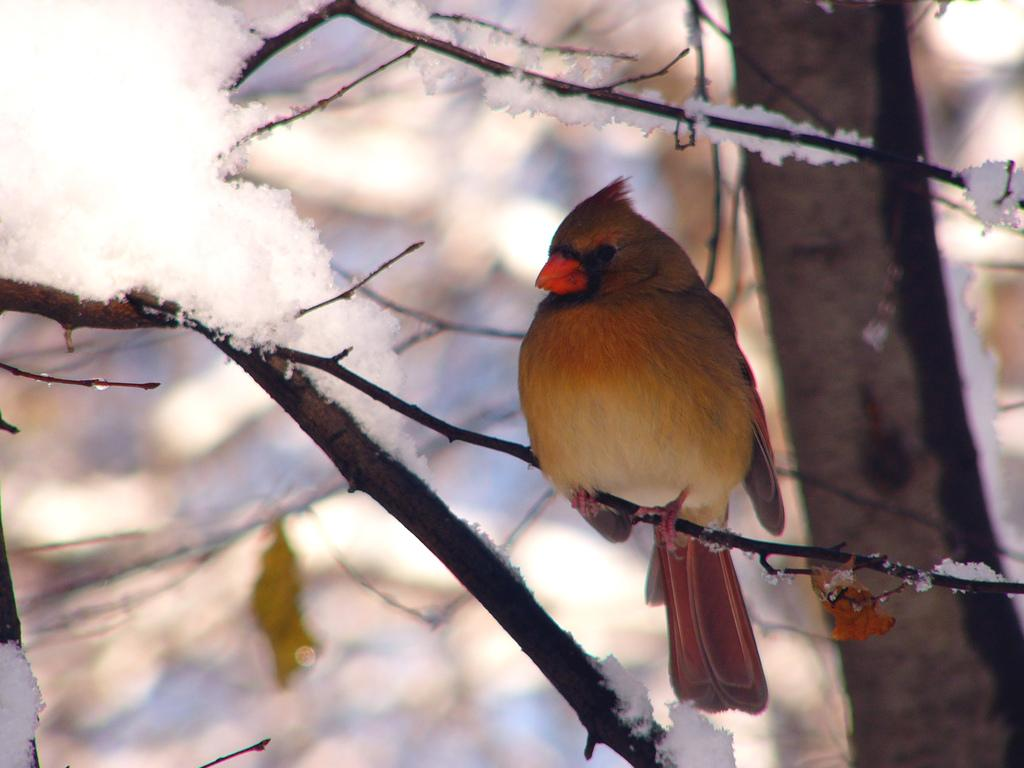What is located in the center of the image? There are branches in the center of the image. Can you describe the branches in more detail? There is one leaf visible on the branches. What else can be seen in the image? There is ice present in the image. Is there any wildlife visible in the image? Yes, there is a bird on one of the branches. How would you describe the background of the image? The background of the image is blurred. What type of tomatoes can be seen growing on the railway tracks in the image? There are no tomatoes or railway tracks present in the image. 